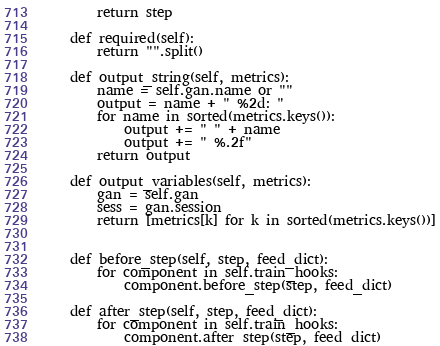Convert code to text. <code><loc_0><loc_0><loc_500><loc_500><_Python_>        return step

    def required(self):
        return "".split()

    def output_string(self, metrics):
        name = self.gan.name or ""
        output = name + " %2d: " 
        for name in sorted(metrics.keys()):
            output += " " + name
            output += " %.2f"
        return output

    def output_variables(self, metrics):
        gan = self.gan
        sess = gan.session
        return [metrics[k] for k in sorted(metrics.keys())]


    def before_step(self, step, feed_dict):
        for component in self.train_hooks:
            component.before_step(step, feed_dict)

    def after_step(self, step, feed_dict):
        for component in self.train_hooks:
            component.after_step(step, feed_dict)
</code> 